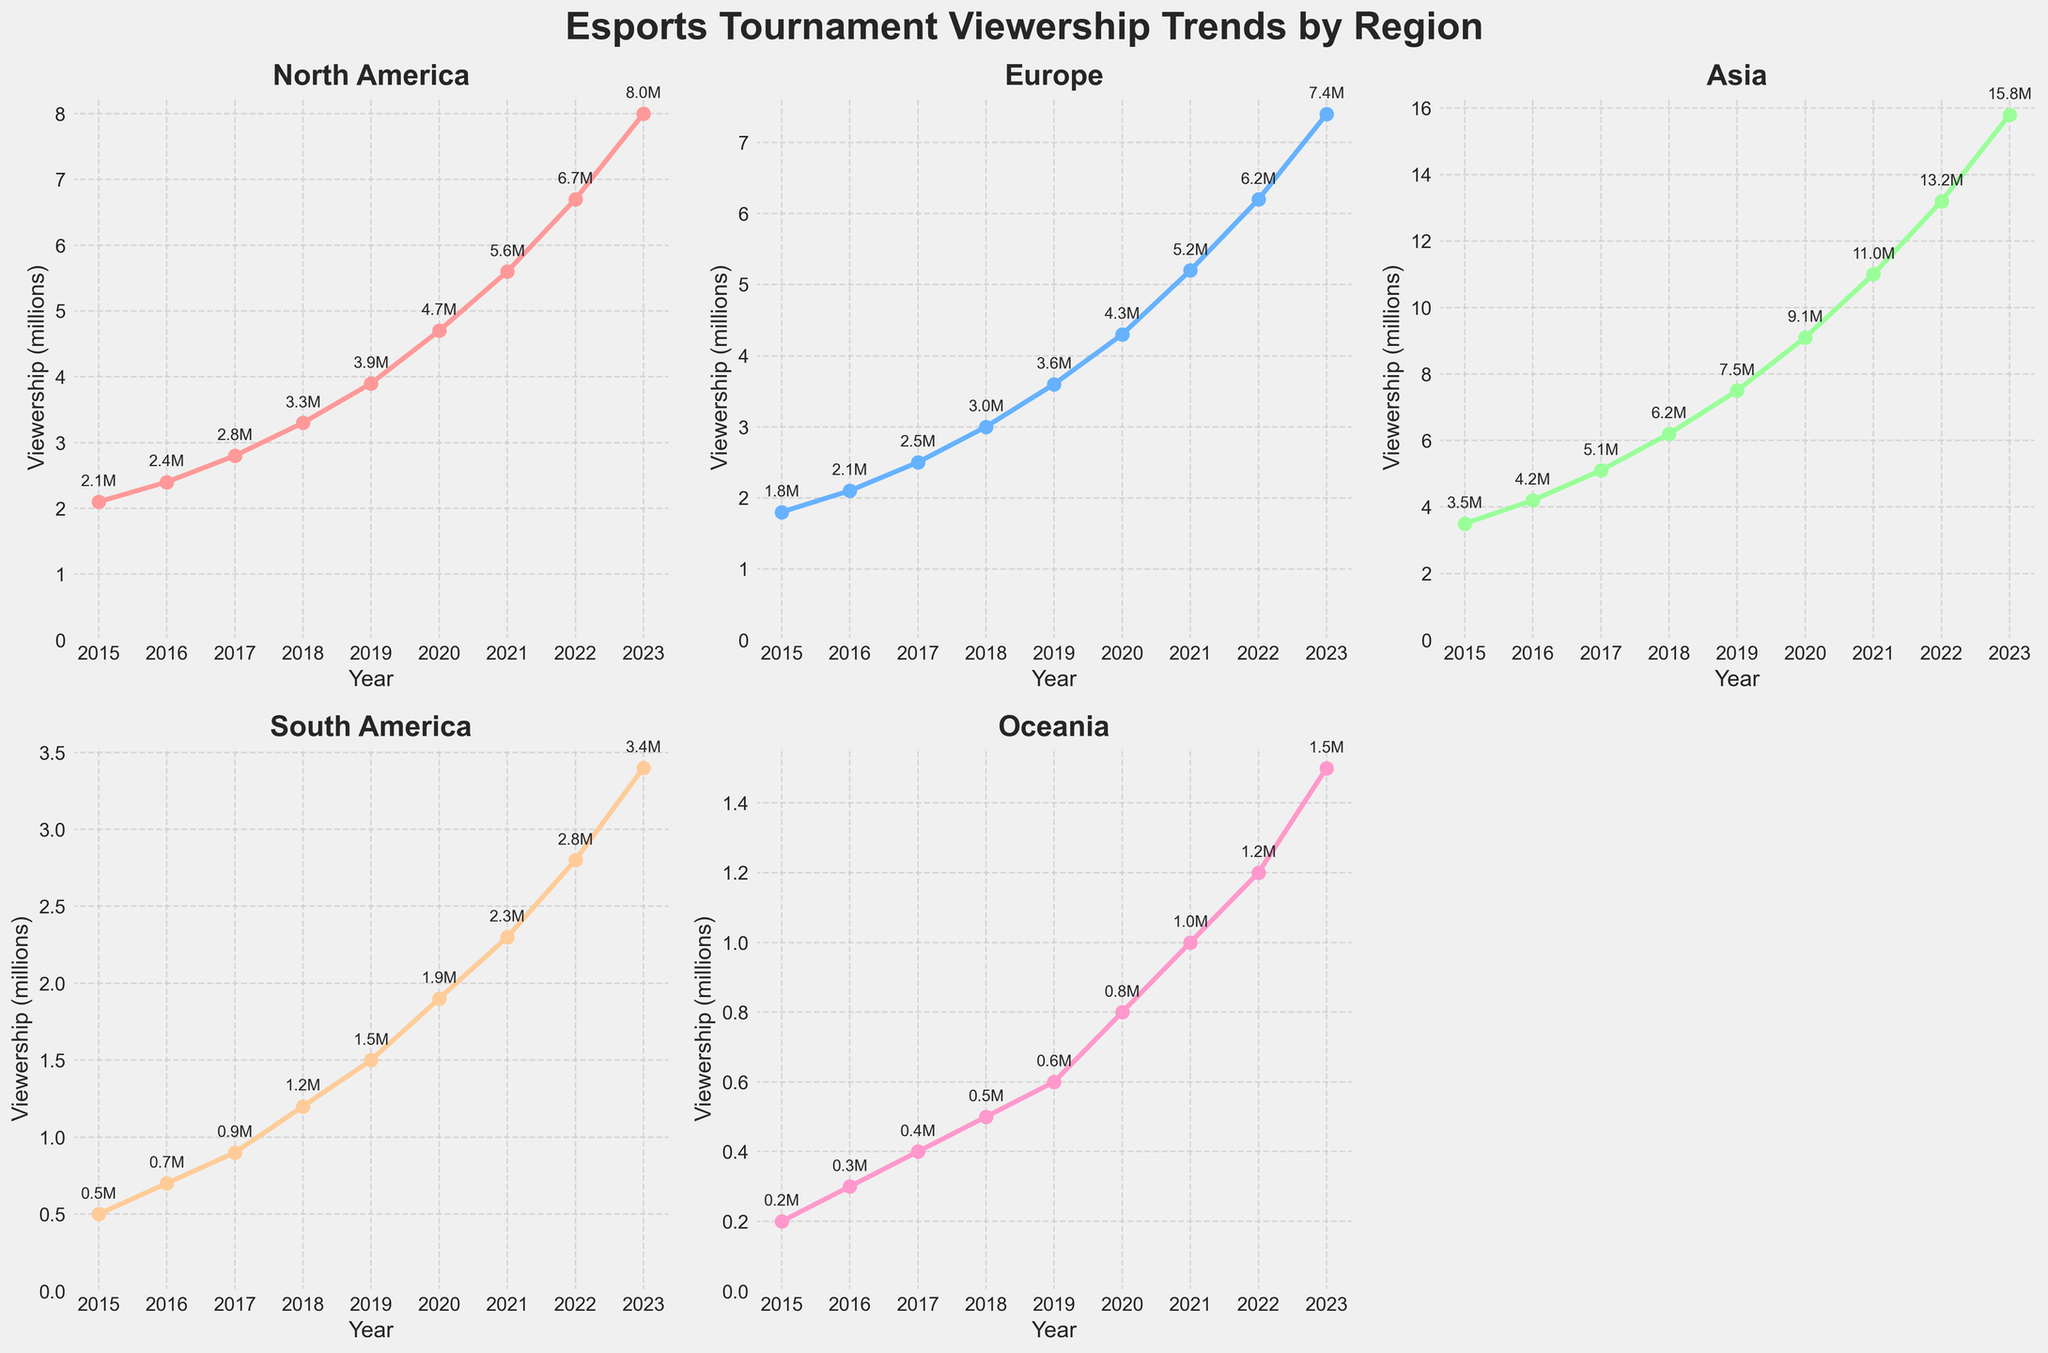What's the total viewership for Asia and North America in 2023? First, identify Asia's viewership in 2023, which is 15.8 million. Next, identify North America's viewership in the same year, which is 8.0 million. Add these two numbers: 15.8 + 8.0 = 23.8 million.
Answer: 23.8 million Which region saw the highest growth in viewership between 2015 and 2023? Calculate the viewership growth for each region from 2015 to 2023:
- North America: 8.0 - 2.1 = 5.9 million
- Europe: 7.4 - 1.8 = 5.6 million
- Asia: 15.8 - 3.5 = 12.3 million
- South America: 3.4 - 0.5 = 2.9 million
- Oceania: 1.5 - 0.2 = 1.3 million
    
The highest growth is in Asia with 12.3 million.
Answer: Asia Did any region have a viewership below 1 million in 2020? Examine the viewership figures for each region in 2020:
- North America: 4.7 million
- Europe: 4.3 million
- Asia: 9.1 million
- South America: 1.9 million
- Oceania: 0.8 million
   
Oceania had a viewership below 1 million in 2020.
Answer: Yes, Oceania Compare the viewership difference between Europe and South America in 2019. Identify the viewership in 2019 for Europe (3.6 million) and South America (1.5 million). Subtract South America's viewership from Europe's: 3.6 - 1.5 = 2.1 million.
Answer: 2.1 million What is the average viewership for Oceania from 2015 to 2023? Sum Oceania's viewership from 2015 to 2023: 
0.2 + 0.3 + 0.4 + 0.5 + 0.6 + 0.8 + 1.0 + 1.2 + 1.5 = 6.5 million. Divide by 9 years to find the average: 6.5 / 9 ≈ 0.72 million.
Answer: 0.72 million Which year did North America's viewership first exceed 5 million? Identify the years and corresponding viewership for North America:
- 2021: 5.6 million (first year exceeding 5 million).
Answer: 2021 Does the general trend of viewership increase or decrease over the years in all regions? Observing the plot, the viewership for all regions shows a rising trend from 2015 to 2023.
Answer: Increase How much did South America's viewership increase from 2018 to 2019? Identify South America's viewership in 2018 (1.2 million) and 2019 (1.5 million). Subtract 2018's figure from 2019's: 1.5 - 1.2 = 0.3 million.
Answer: 0.3 million 